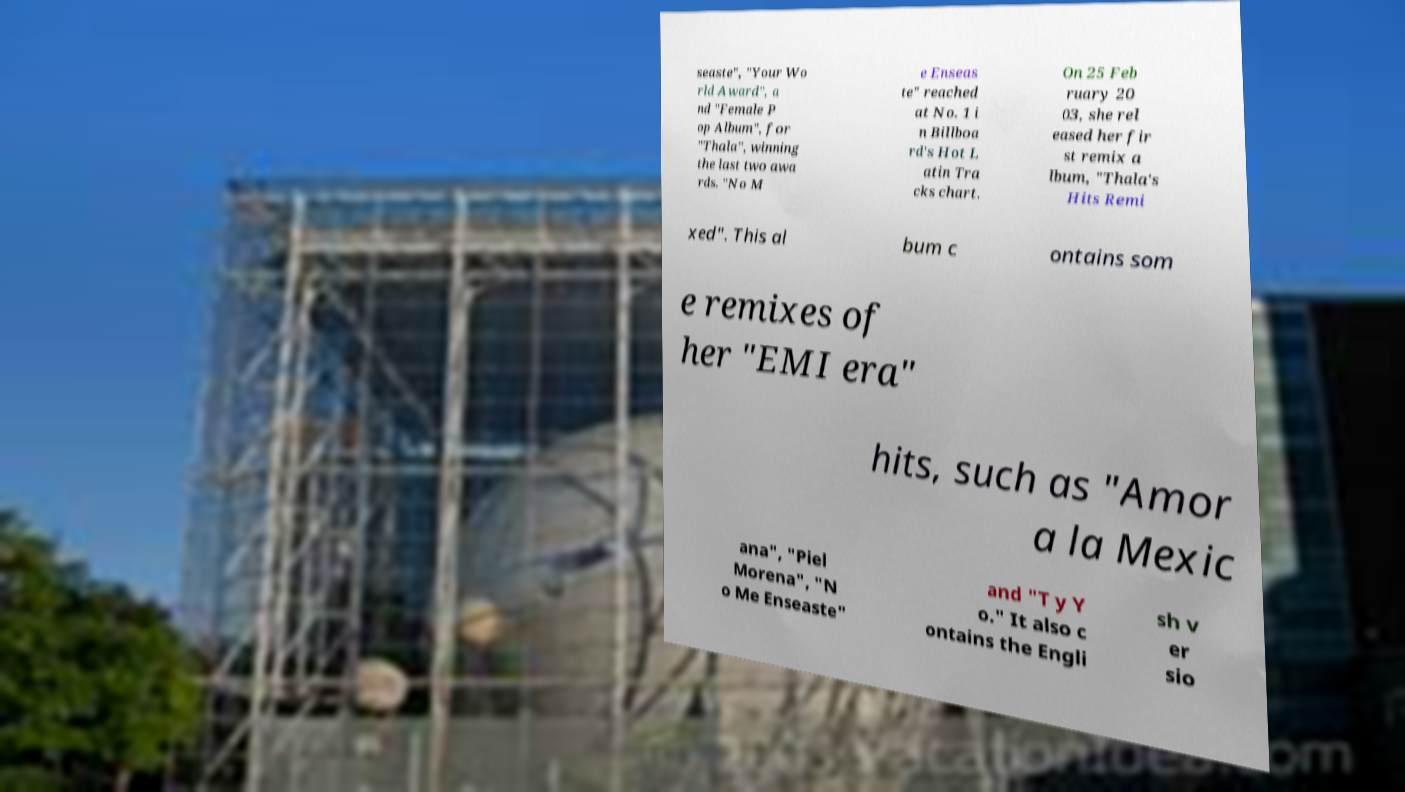Could you assist in decoding the text presented in this image and type it out clearly? seaste", "Your Wo rld Award", a nd "Female P op Album", for "Thala", winning the last two awa rds. "No M e Enseas te" reached at No. 1 i n Billboa rd's Hot L atin Tra cks chart. On 25 Feb ruary 20 03, she rel eased her fir st remix a lbum, "Thala's Hits Remi xed". This al bum c ontains som e remixes of her "EMI era" hits, such as "Amor a la Mexic ana", "Piel Morena", "N o Me Enseaste" and "T y Y o." It also c ontains the Engli sh v er sio 